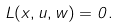<formula> <loc_0><loc_0><loc_500><loc_500>L ( x , u , w ) = 0 .</formula> 